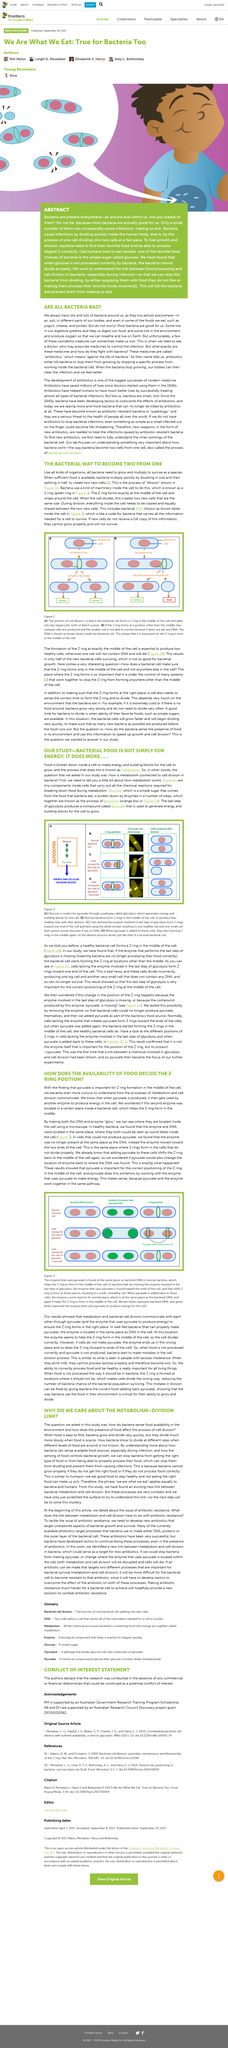List a handful of essential elements in this visual. Metabolism is the process by which the body converts food into energy, through the breakdown of nutrients within cells. The Z ring forms in the middle of the cell. Pyruvate is a compound that serves as a key building block for the growth and development of cells. The term 'Z Ring' is used three times in total, including once in the title, in this article. Glucose is a type of simple sugar that is derived from the food consumed by bacteria. 